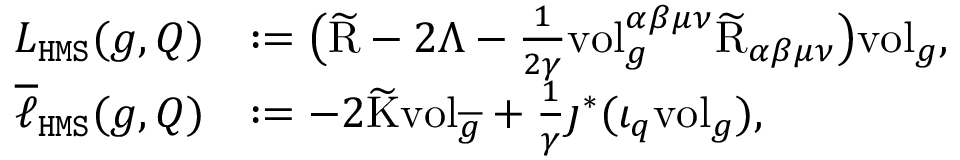Convert formula to latex. <formula><loc_0><loc_0><loc_500><loc_500>\begin{array} { r l } { L _ { H M S } ( g , Q ) } & { \colon = \left ( \widetilde { R } - 2 \Lambda - \frac { 1 } { 2 \gamma } v o l _ { g } ^ { \alpha \beta \mu \nu } \widetilde { R } _ { \alpha \beta \mu \nu } \right ) v o l _ { g } , } \\ { \overline { \ell } _ { H M S } ( g , Q ) } & { \colon = - 2 \widetilde { K } v o l _ { \overline { g } } + \frac { 1 } { \gamma } \jmath ^ { * } ( \iota _ { q } v o l _ { g } ) , } \end{array}</formula> 